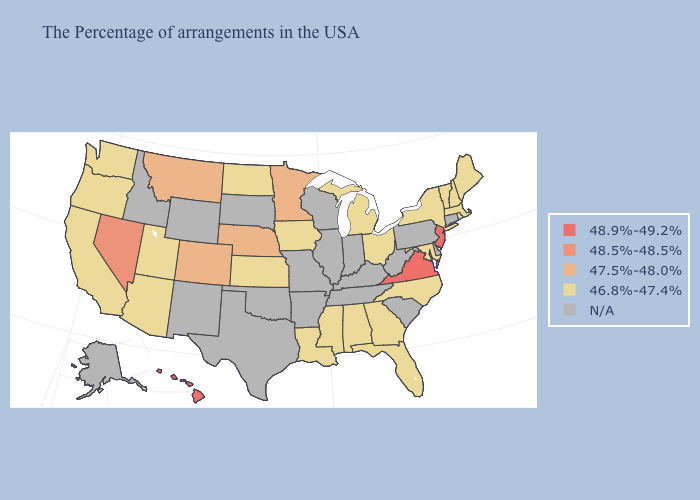What is the highest value in states that border Rhode Island?
Give a very brief answer. 46.8%-47.4%. What is the value of Missouri?
Quick response, please. N/A. Does Michigan have the highest value in the USA?
Concise answer only. No. What is the highest value in the South ?
Concise answer only. 48.9%-49.2%. Does Colorado have the lowest value in the USA?
Write a very short answer. No. Does Georgia have the highest value in the South?
Concise answer only. No. What is the value of North Dakota?
Be succinct. 46.8%-47.4%. Does Oregon have the lowest value in the West?
Keep it brief. Yes. What is the value of West Virginia?
Write a very short answer. N/A. Does the first symbol in the legend represent the smallest category?
Concise answer only. No. Which states hav the highest value in the Northeast?
Write a very short answer. New Jersey. Name the states that have a value in the range N/A?
Write a very short answer. Connecticut, Delaware, Pennsylvania, South Carolina, West Virginia, Kentucky, Indiana, Tennessee, Wisconsin, Illinois, Missouri, Arkansas, Oklahoma, Texas, South Dakota, Wyoming, New Mexico, Idaho, Alaska. What is the lowest value in the USA?
Quick response, please. 46.8%-47.4%. Is the legend a continuous bar?
Short answer required. No. 